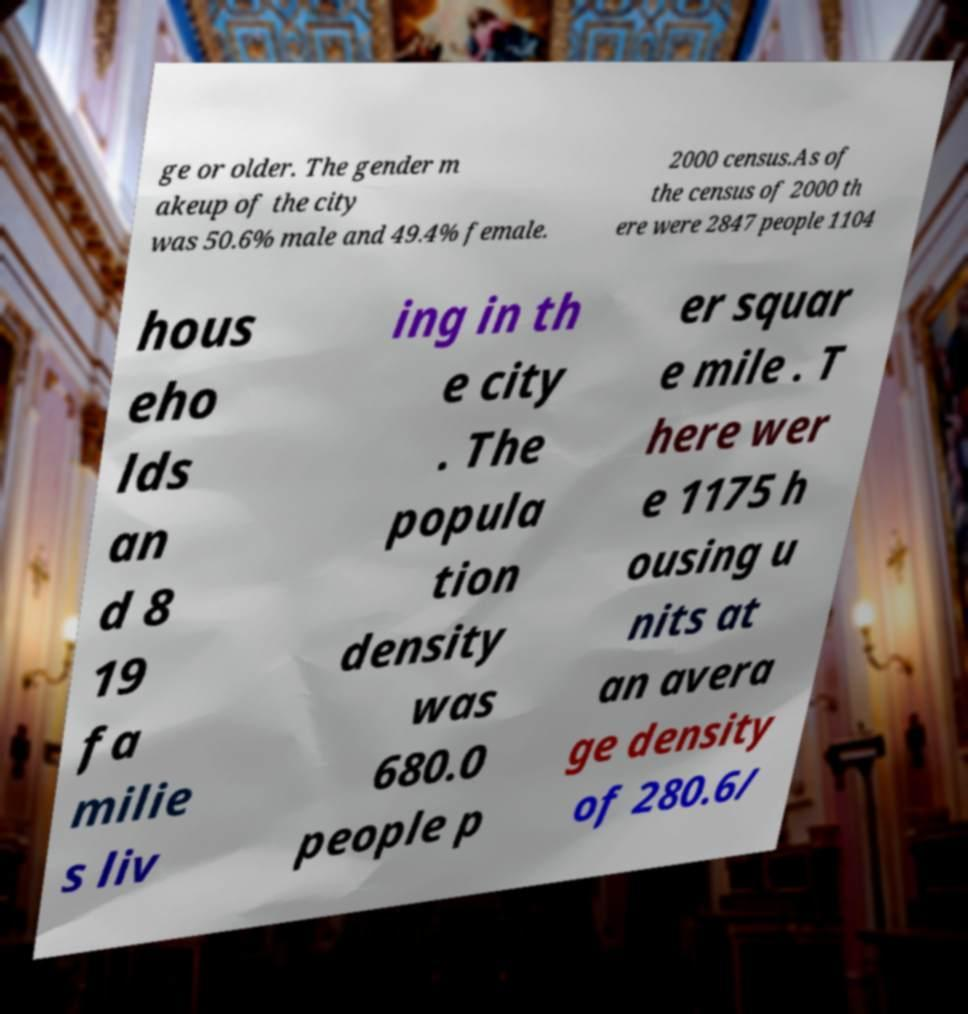Could you extract and type out the text from this image? ge or older. The gender m akeup of the city was 50.6% male and 49.4% female. 2000 census.As of the census of 2000 th ere were 2847 people 1104 hous eho lds an d 8 19 fa milie s liv ing in th e city . The popula tion density was 680.0 people p er squar e mile . T here wer e 1175 h ousing u nits at an avera ge density of 280.6/ 